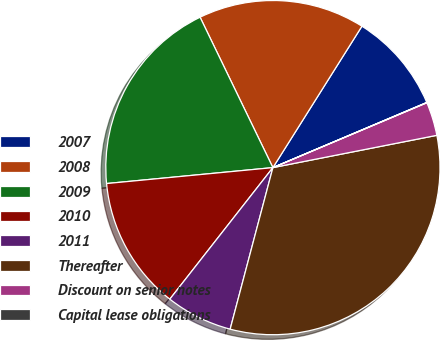<chart> <loc_0><loc_0><loc_500><loc_500><pie_chart><fcel>2007<fcel>2008<fcel>2009<fcel>2010<fcel>2011<fcel>Thereafter<fcel>Discount on senior notes<fcel>Capital lease obligations<nl><fcel>9.68%<fcel>16.12%<fcel>19.34%<fcel>12.9%<fcel>6.46%<fcel>32.21%<fcel>3.25%<fcel>0.03%<nl></chart> 